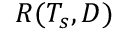Convert formula to latex. <formula><loc_0><loc_0><loc_500><loc_500>R ( T _ { s } , D )</formula> 